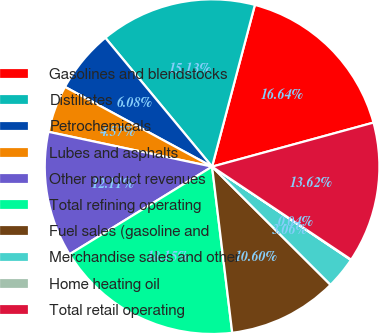Convert chart to OTSL. <chart><loc_0><loc_0><loc_500><loc_500><pie_chart><fcel>Gasolines and blendstocks<fcel>Distillates<fcel>Petrochemicals<fcel>Lubes and asphalts<fcel>Other product revenues<fcel>Total refining operating<fcel>Fuel sales (gasoline and<fcel>Merchandise sales and other<fcel>Home heating oil<fcel>Total retail operating<nl><fcel>16.64%<fcel>15.13%<fcel>6.08%<fcel>4.57%<fcel>12.11%<fcel>18.15%<fcel>10.6%<fcel>3.06%<fcel>0.04%<fcel>13.62%<nl></chart> 